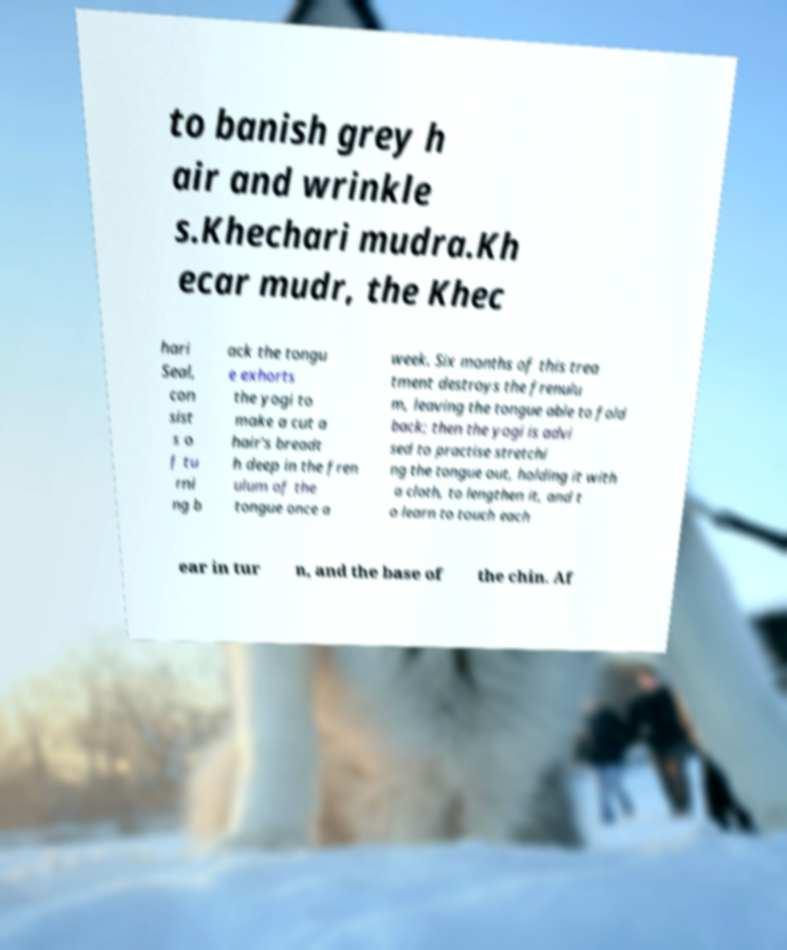What messages or text are displayed in this image? I need them in a readable, typed format. to banish grey h air and wrinkle s.Khechari mudra.Kh ecar mudr, the Khec hari Seal, con sist s o f tu rni ng b ack the tongu e exhorts the yogi to make a cut a hair's breadt h deep in the fren ulum of the tongue once a week. Six months of this trea tment destroys the frenulu m, leaving the tongue able to fold back; then the yogi is advi sed to practise stretchi ng the tongue out, holding it with a cloth, to lengthen it, and t o learn to touch each ear in tur n, and the base of the chin. Af 